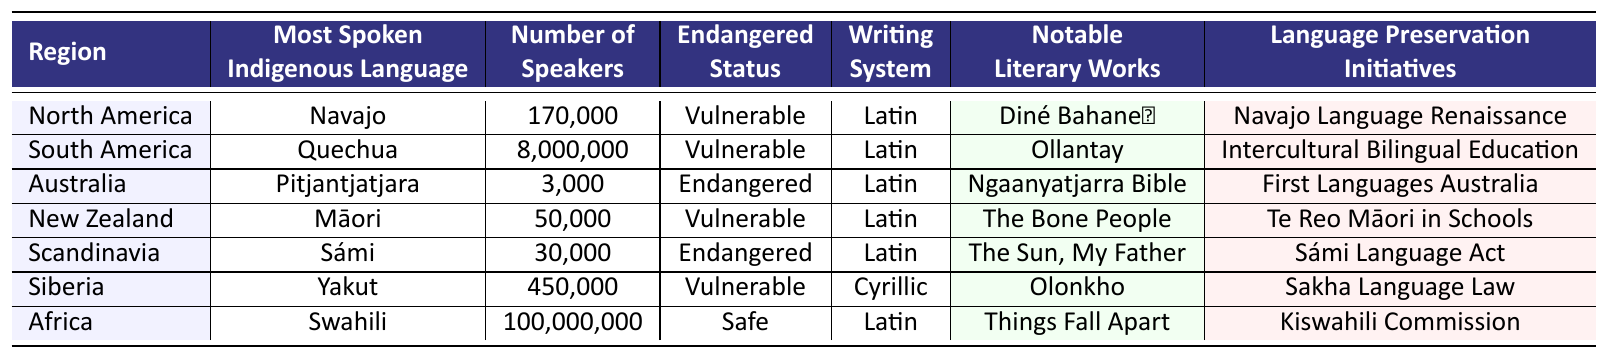What is the most spoken Indigenous language in North America? The table lists "Navajo" as the most spoken Indigenous language in North America under the "Most Spoken Indigenous Language" column.
Answer: Navajo How many speakers does the Quechua language have? According to the table, the "Number of Speakers" for Quechua is 8,000,000 as listed under the respective row for South America.
Answer: 8,000,000 Which Indigenous language has an endangered status in Australia? The table identifies "Pitjantjatjara" as the Indigenous language with an "Endangered" status in the row for Australia.
Answer: Pitjantjatjara What writing system is used for the Sámi language? The data indicates that the "Writing System" for Sámi is "Latin," as shown in the corresponding row for Scandinavia.
Answer: Latin Is Swahili considered an endangered language? The table shows that Swahili has a "Safe" endangered status, which means it is not endangered.
Answer: No What is the total number of speakers for all languages listed in the table? To find the total, we sum the number of speakers: 170,000 + 8,000,000 + 3,000 + 50,000 + 30,000 + 450,000 + 100,000,000 = 108,703,000.
Answer: 108,703,000 In which region is the most spoken Indigenous language associated with the Cyrillic writing system? The table shows that Yakut, the most spoken Indigenous language in Siberia, uses the Cyrillic writing system.
Answer: Siberia Are there more speakers of Māori or Sámi? The table shows that Māori has 50,000 speakers and Sámi has 30,000 speakers, so Māori has more speakers than Sámi.
Answer: Māori What notable literary work is associated with the Yakut language? The Yakut language is associated with the notable literary work "Olonkho," as indicated in the table under the relevant row.
Answer: Olonkho Which region has the highest number of speakers and what is that number? Africa has the highest number of speakers with 100,000,000 speakers indicated in the table.
Answer: 100,000,000 